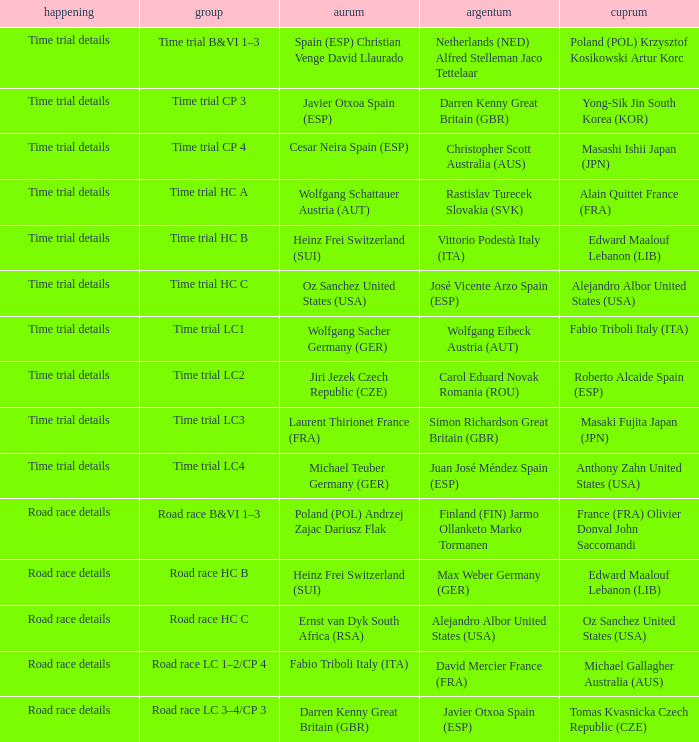What is the event when the class is time trial hc a? Time trial details. 